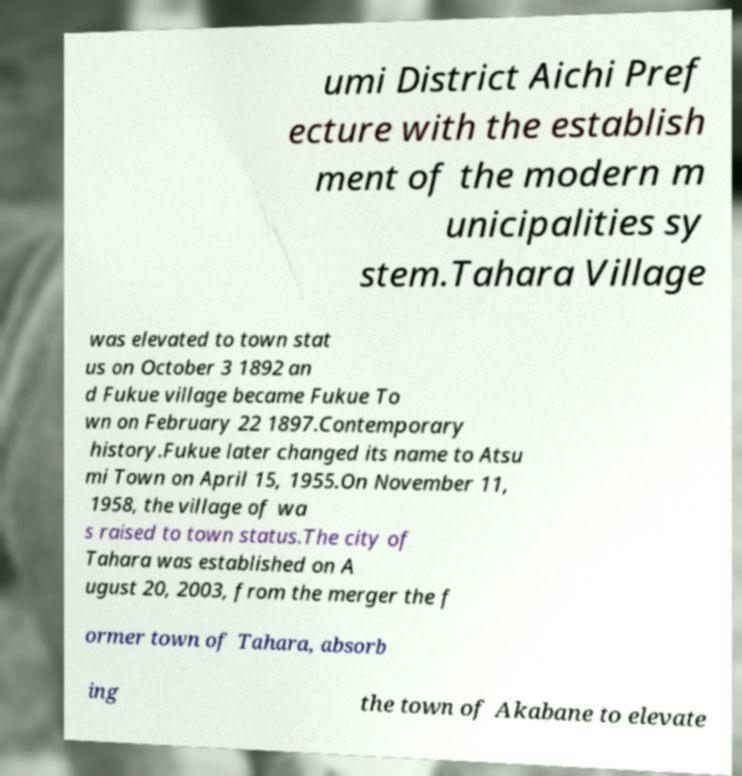Please read and relay the text visible in this image. What does it say? umi District Aichi Pref ecture with the establish ment of the modern m unicipalities sy stem.Tahara Village was elevated to town stat us on October 3 1892 an d Fukue village became Fukue To wn on February 22 1897.Contemporary history.Fukue later changed its name to Atsu mi Town on April 15, 1955.On November 11, 1958, the village of wa s raised to town status.The city of Tahara was established on A ugust 20, 2003, from the merger the f ormer town of Tahara, absorb ing the town of Akabane to elevate 